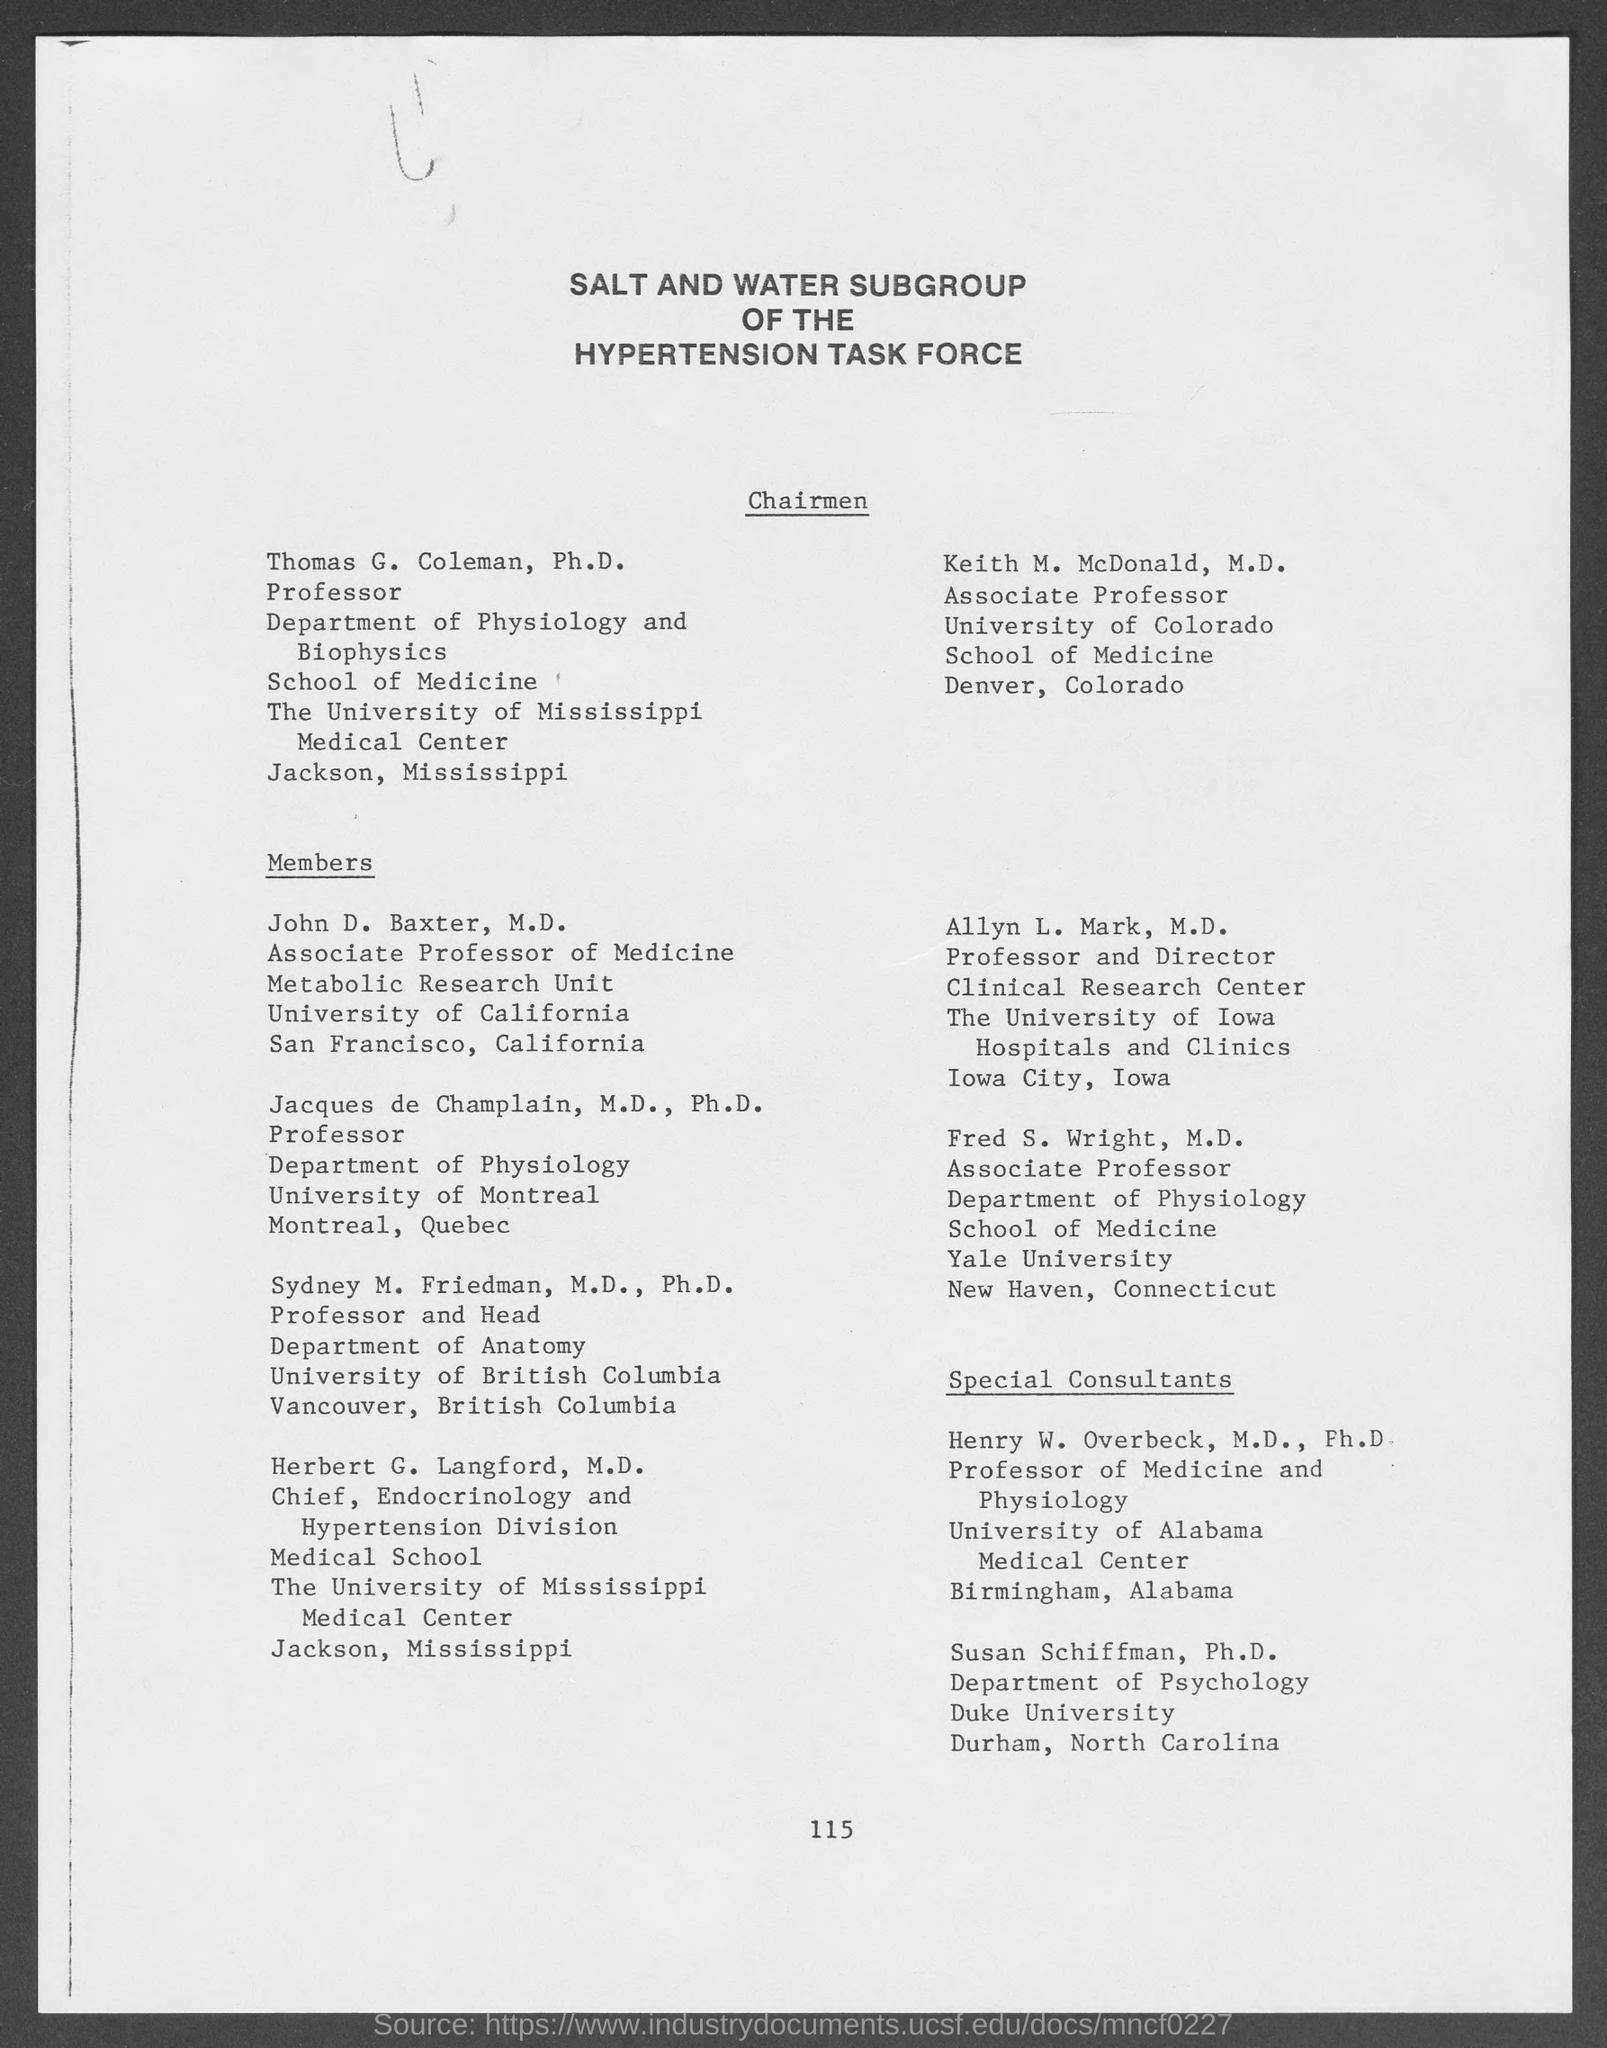Identify some key points in this picture. Keith M. McDonald, M.D. is an associate professor. John D. Baxter, M.D. is an associate professor of medicine. Sydney M. Friedman, M.D., Ph.D. belongs to the department of anatomy. Fred S. Wright, M.D. holds the position of associate professor. Henry W. Overbeck, M.D., Ph.D., holds the position of professor of medicine and physiology. 